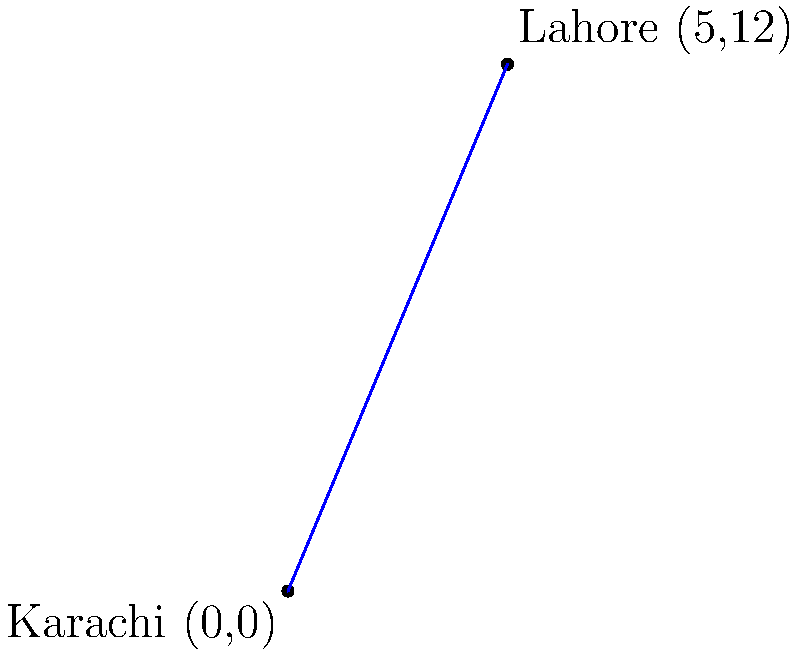As a trade expert, you're analyzing the economic corridor between two major Pakistani cities: Karachi and Lahore. On a coordinate plane, Karachi is located at (0,0) and Lahore at (5,12). Using the distance formula, calculate the direct distance between these two trade hubs. Round your answer to the nearest whole number. To solve this problem, we'll use the distance formula derived from the Pythagorean theorem:

$$d = \sqrt{(x_2-x_1)^2 + (y_2-y_1)^2}$$

Where $(x_1,y_1)$ is the coordinate of Karachi and $(x_2,y_2)$ is the coordinate of Lahore.

Step 1: Identify the coordinates
Karachi: $(x_1,y_1) = (0,0)$
Lahore: $(x_2,y_2) = (5,12)$

Step 2: Plug the coordinates into the formula
$$d = \sqrt{(5-0)^2 + (12-0)^2}$$

Step 3: Simplify inside the parentheses
$$d = \sqrt{5^2 + 12^2}$$

Step 4: Calculate the squares
$$d = \sqrt{25 + 144}$$

Step 5: Add inside the square root
$$d = \sqrt{169}$$

Step 6: Calculate the square root
$$d = 13$$

Therefore, the distance between Karachi and Lahore on this coordinate system is 13 units.
Answer: 13 units 